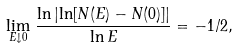<formula> <loc_0><loc_0><loc_500><loc_500>\lim _ { E \downarrow 0 } \, \frac { \ln \left | \ln [ N ( E ) - N ( 0 ) ] \right | } { \ln E } = - 1 / 2 ,</formula> 